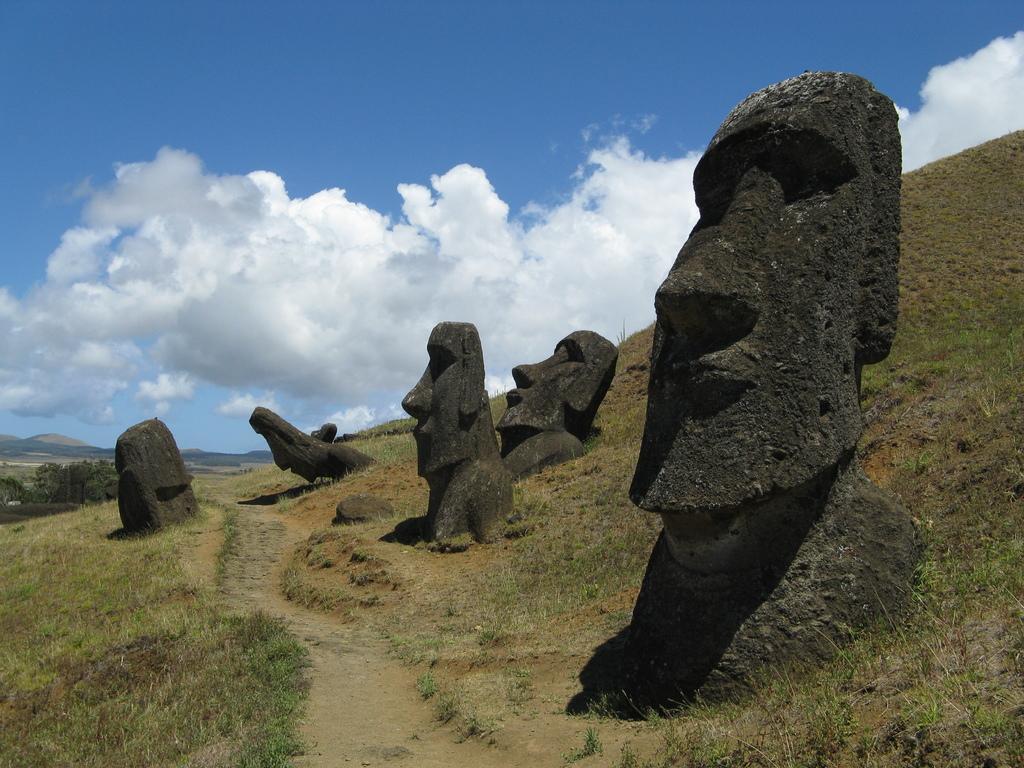In one or two sentences, can you explain what this image depicts? There is a path at the bottom side of the image, it seems like statues on the grassland in the center. There are trees, it seems like mountains and sky in the background area. 